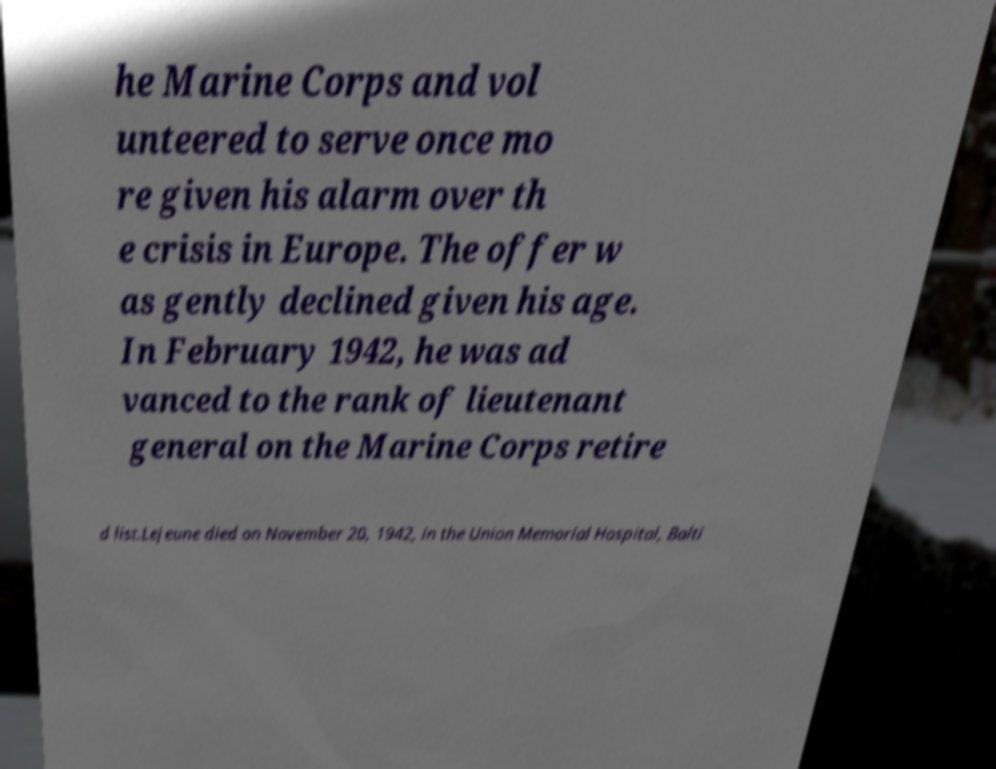I need the written content from this picture converted into text. Can you do that? he Marine Corps and vol unteered to serve once mo re given his alarm over th e crisis in Europe. The offer w as gently declined given his age. In February 1942, he was ad vanced to the rank of lieutenant general on the Marine Corps retire d list.Lejeune died on November 20, 1942, in the Union Memorial Hospital, Balti 